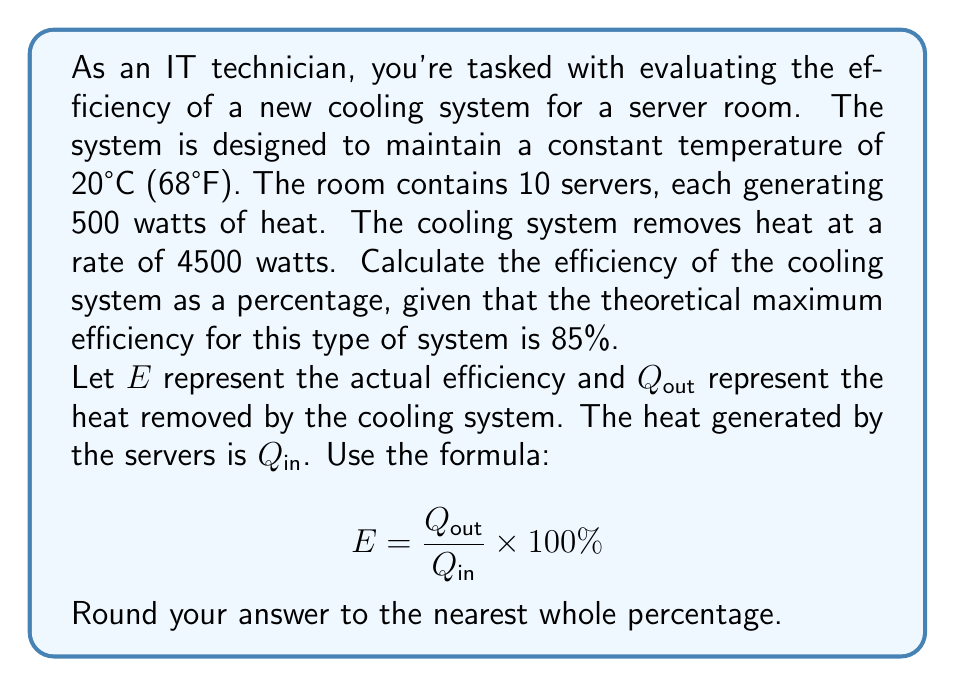Give your solution to this math problem. To solve this problem, we'll follow these steps:

1. Calculate the total heat generated by the servers ($Q_{in}$):
   $$Q_{in} = 10 \text{ servers} \times 500 \text{ watts} = 5000 \text{ watts}$$

2. Identify the heat removed by the cooling system ($Q_{out}$):
   $$Q_{out} = 4500 \text{ watts}$$

3. Calculate the actual efficiency using the given formula:
   $$E = \frac{Q_{out}}{Q_{in}} \times 100\%$$
   $$E = \frac{4500 \text{ watts}}{5000 \text{ watts}} \times 100\%$$
   $$E = 0.9 \times 100\% = 90\%$$

4. Compare the actual efficiency to the theoretical maximum:
   The actual efficiency (90%) is higher than the theoretical maximum (85%), which is not possible in reality. This suggests that the cooling system is operating at its maximum capacity.

5. Adjust the efficiency to the theoretical maximum:
   Since the calculated efficiency exceeds the theoretical maximum, we conclude that the system is operating at its maximum efficiency of 85%.

6. Round the answer to the nearest whole percentage:
   85% (no rounding needed in this case)
Answer: 85% 